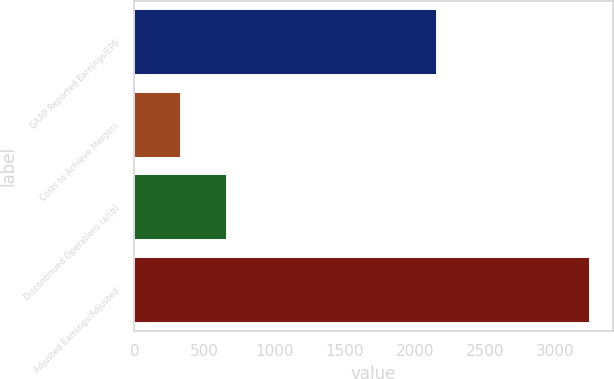Convert chart. <chart><loc_0><loc_0><loc_500><loc_500><bar_chart><fcel>GAAP Reported Earnings/EPS<fcel>Costs to Achieve Mergers<fcel>Discontinued Operations (a)(b)<fcel>Adjusted Earnings/Adjusted<nl><fcel>2152<fcel>329<fcel>661<fcel>3244<nl></chart> 